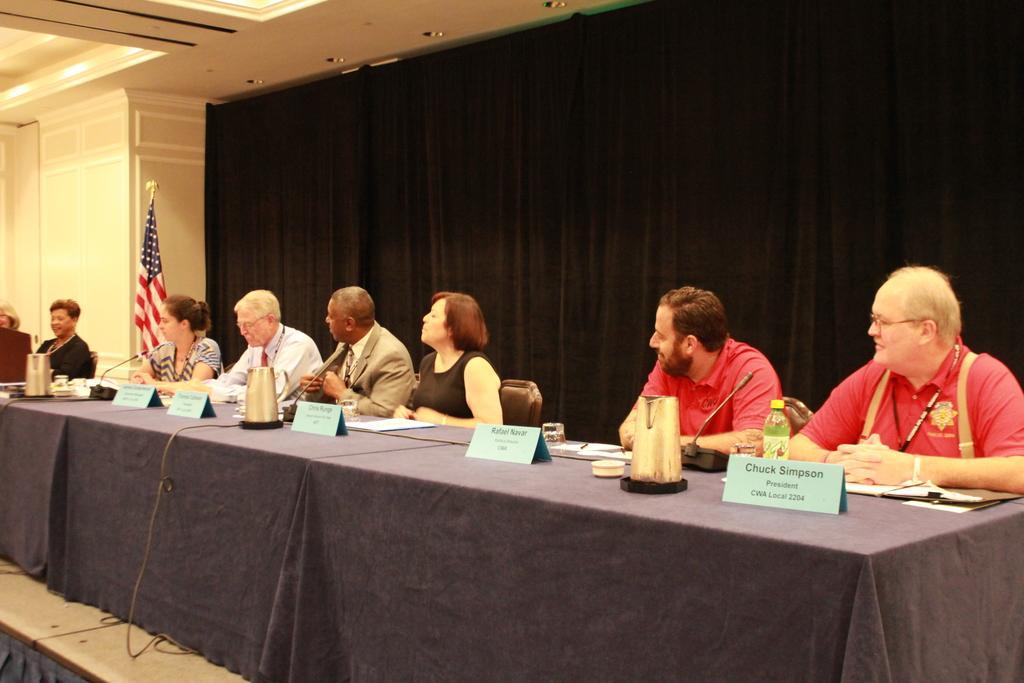In one or two sentences, can you explain what this image depicts? In this picture we can see some persons are sitting on the chairs. This is the table, on the table there is a cloth, jar, bottle, and paper. This is the bottle. On the background we can see a curtain. This is the flag and there is a wall. And there are the lights. 